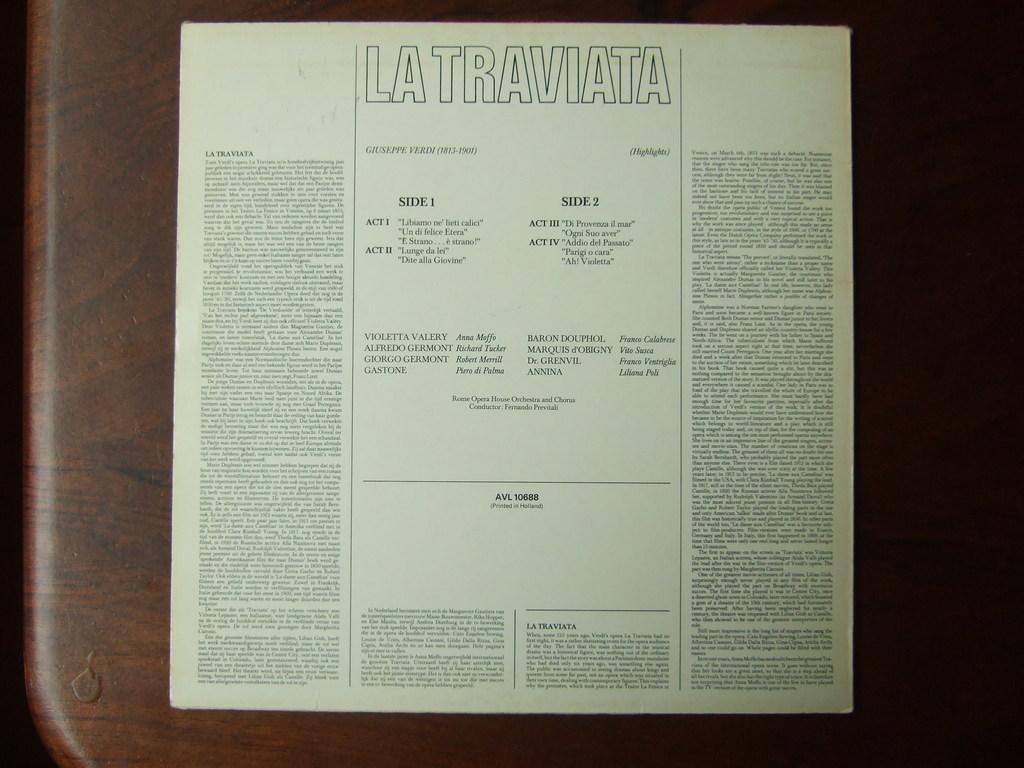<image>
Give a short and clear explanation of the subsequent image. a page that says 'la traviata' at the top 